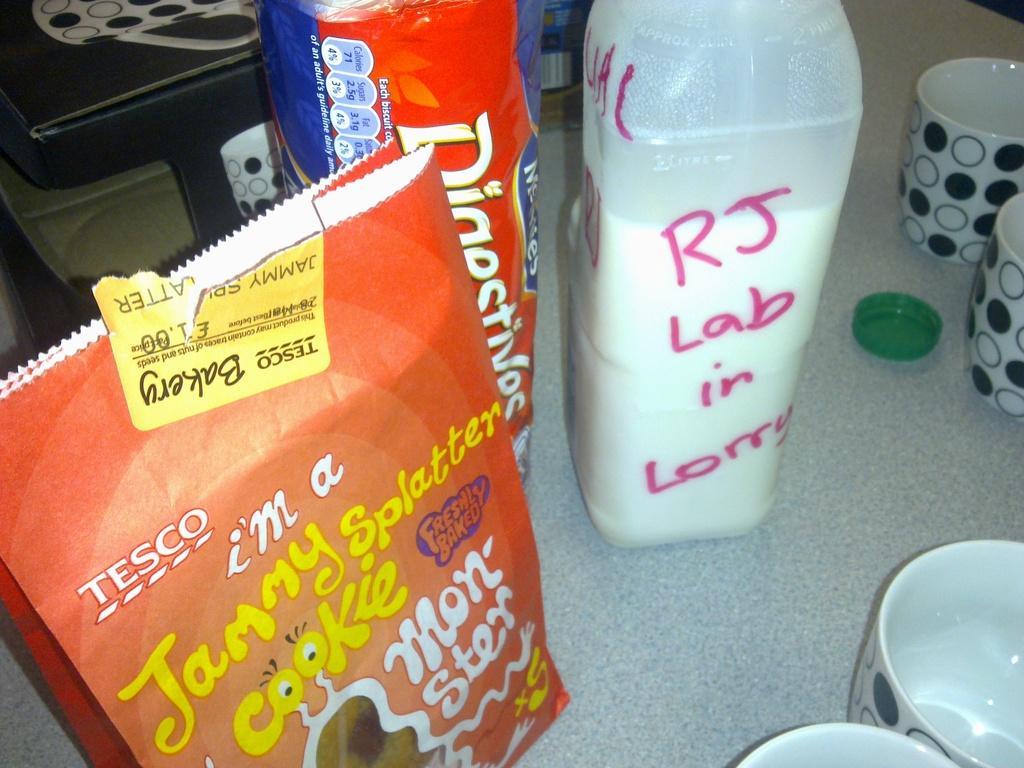Could you give a brief overview of what you see in this image? In this picture we can see cups, cap, milk bottle, packs. 